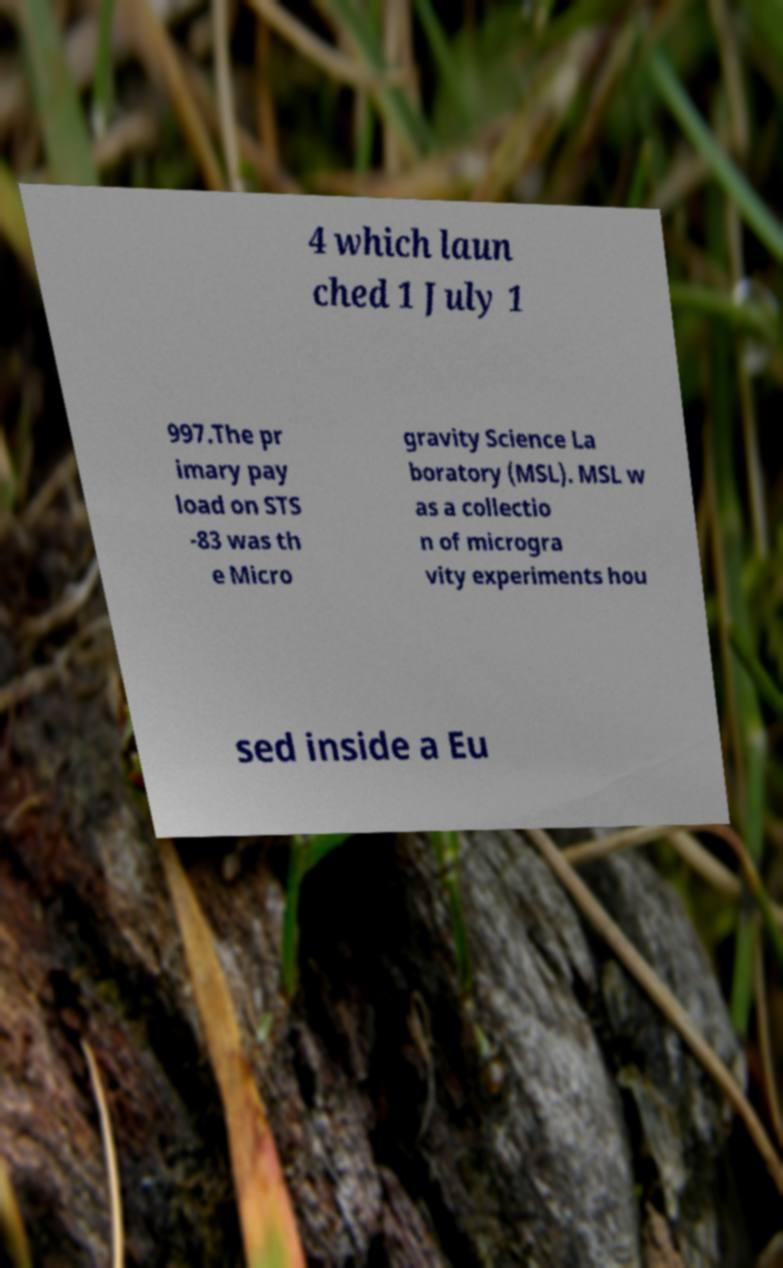For documentation purposes, I need the text within this image transcribed. Could you provide that? 4 which laun ched 1 July 1 997.The pr imary pay load on STS -83 was th e Micro gravity Science La boratory (MSL). MSL w as a collectio n of microgra vity experiments hou sed inside a Eu 